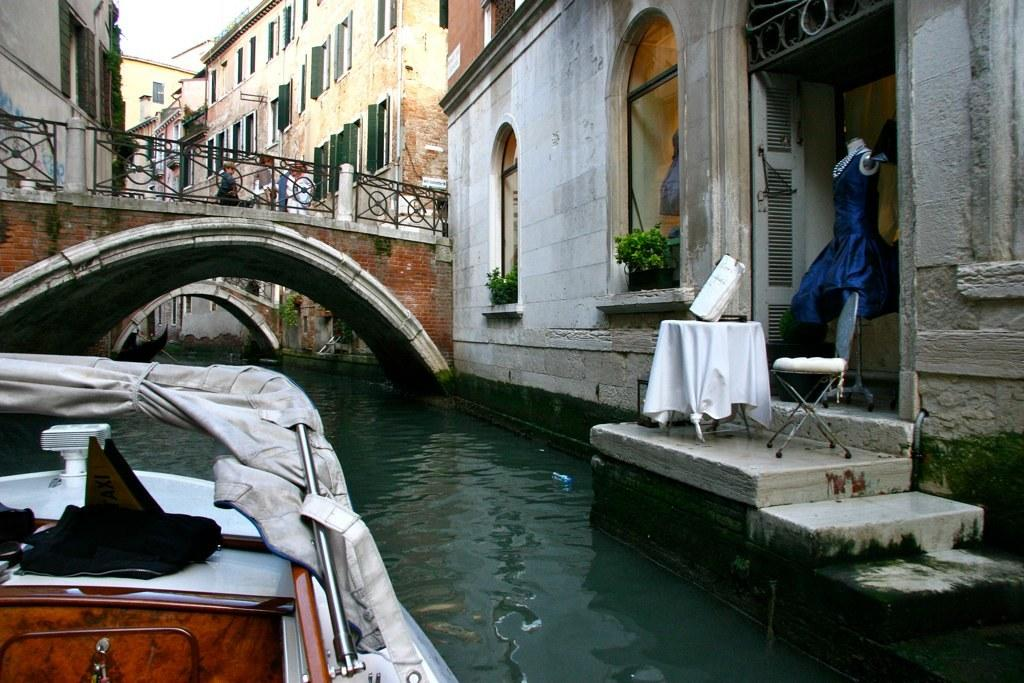What is the main subject of the image? The main subject of the image is a boat. Where is the boat located? The boat is on a canal. What can be seen on the right side of the image? There are buildings on the right side of the image. Is there any infrastructure visible in the image? Yes, there is a bridge across the canal in the image. How many cars are parked near the jail in the image? There is no jail or cars present in the image; it features a boat on a canal with a bridge and buildings in the background. 